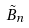Convert formula to latex. <formula><loc_0><loc_0><loc_500><loc_500>\tilde { B } _ { n }</formula> 